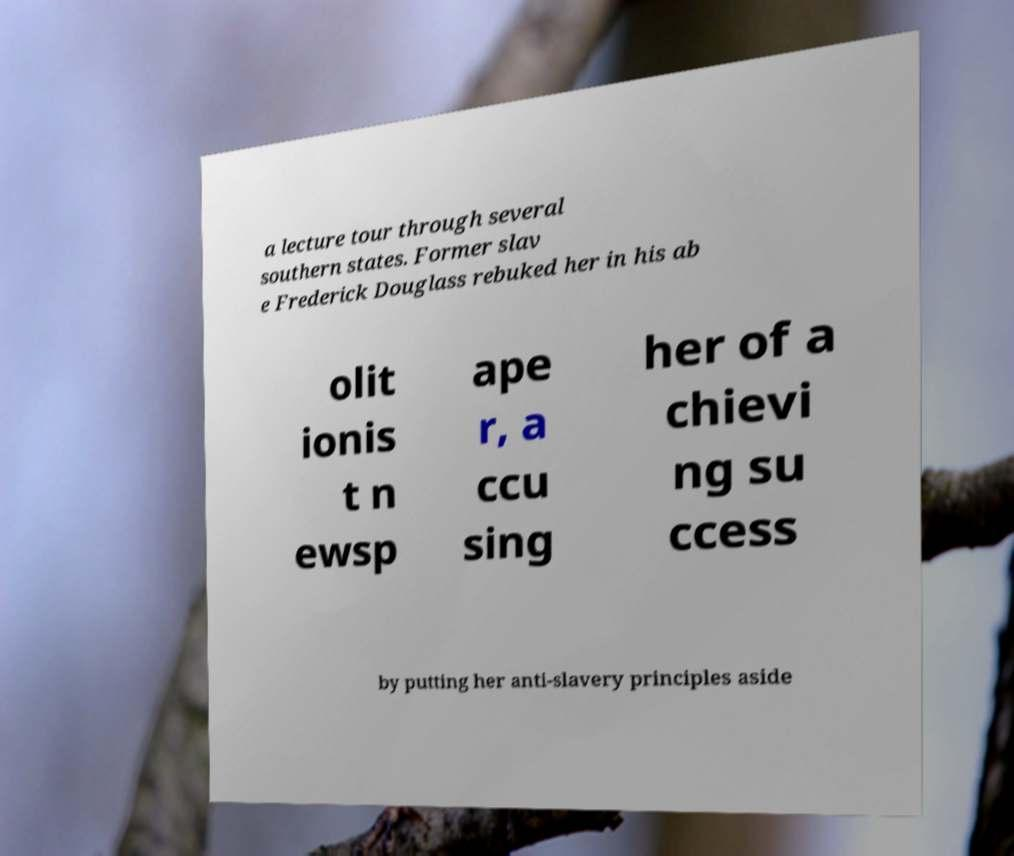What messages or text are displayed in this image? I need them in a readable, typed format. a lecture tour through several southern states. Former slav e Frederick Douglass rebuked her in his ab olit ionis t n ewsp ape r, a ccu sing her of a chievi ng su ccess by putting her anti-slavery principles aside 